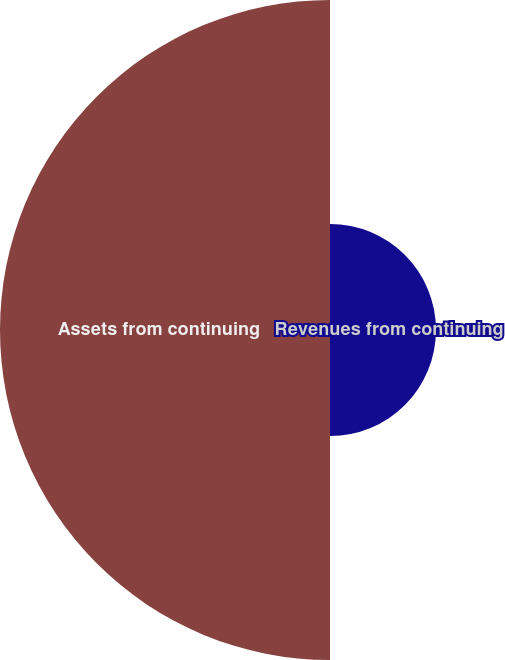Convert chart to OTSL. <chart><loc_0><loc_0><loc_500><loc_500><pie_chart><fcel>Revenues from continuing<fcel>Assets from continuing<nl><fcel>24.31%<fcel>75.69%<nl></chart> 